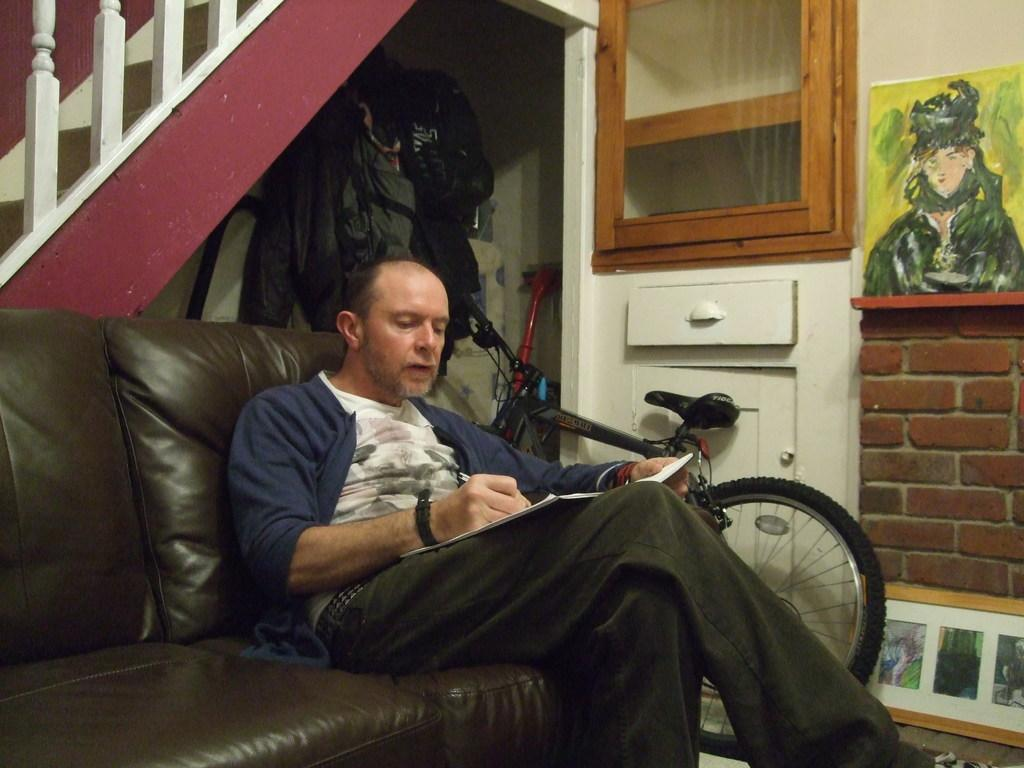What is the man in the image doing? The man is sitting on a sofa in the image. What object is near the man? The man is near a bicycle. What can be seen on the wall in the image? There is a painting on the wall. What type of furniture is on the wall in the image? There is a shelf on the wall. What type of letters can be seen in the scene depicted in the painting? There are no letters visible in the image, and the painting's content is not described in the provided facts. Can you describe the robin that is perched on the shelf in the image? There is no robin present in the image; the only bird mentioned is the painting, which is not described in detail. 